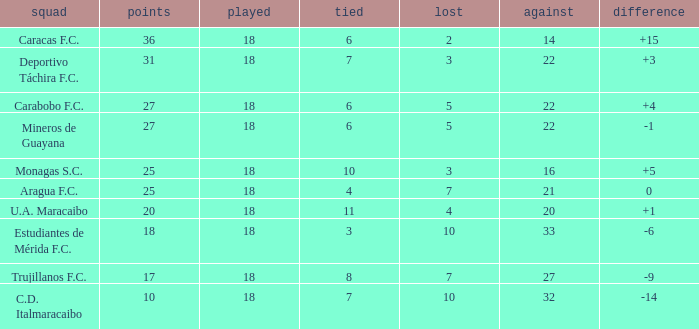What is the average against score of all teams with less than 7 losses, more than 6 draws, and 25 points? 16.0. 